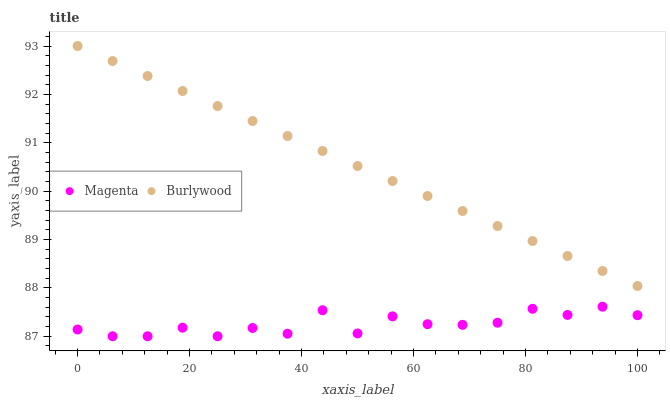Does Magenta have the minimum area under the curve?
Answer yes or no. Yes. Does Burlywood have the maximum area under the curve?
Answer yes or no. Yes. Does Magenta have the maximum area under the curve?
Answer yes or no. No. Is Burlywood the smoothest?
Answer yes or no. Yes. Is Magenta the roughest?
Answer yes or no. Yes. Is Magenta the smoothest?
Answer yes or no. No. Does Magenta have the lowest value?
Answer yes or no. Yes. Does Burlywood have the highest value?
Answer yes or no. Yes. Does Magenta have the highest value?
Answer yes or no. No. Is Magenta less than Burlywood?
Answer yes or no. Yes. Is Burlywood greater than Magenta?
Answer yes or no. Yes. Does Magenta intersect Burlywood?
Answer yes or no. No. 